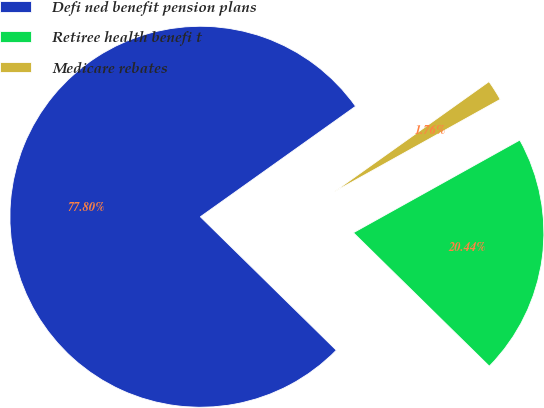Convert chart to OTSL. <chart><loc_0><loc_0><loc_500><loc_500><pie_chart><fcel>Defi ned benefit pension plans<fcel>Retiree health benefi t<fcel>Medicare rebates<nl><fcel>77.8%<fcel>20.44%<fcel>1.76%<nl></chart> 